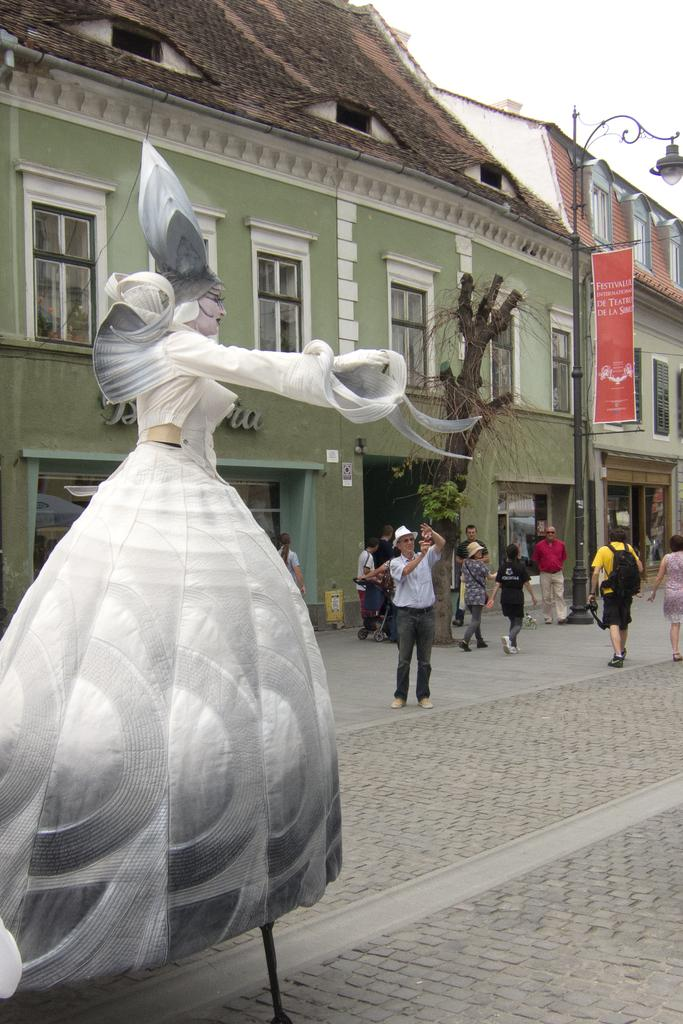What is the main subject of the image? There is a clown in the image. What can be seen in the background of the image? There are people, buildings, a pole with a light, and a road visible in the background of the image. Can you describe the people in the background? Some people in the background are wearing caps. What type of mark can be seen on the curtain in the image? There is no curtain present in the image, so it is not possible to determine if there is a mark on it. 